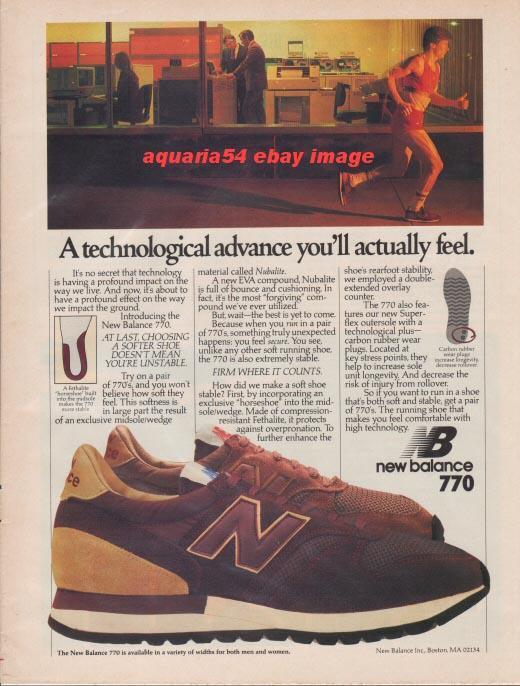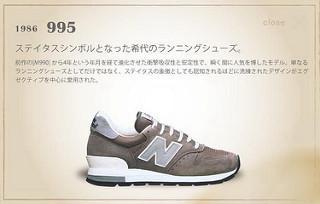The first image is the image on the left, the second image is the image on the right. For the images shown, is this caption "The shoes in each of the images are depicted in an advertisement." true? Answer yes or no. Yes. The first image is the image on the left, the second image is the image on the right. Assess this claim about the two images: "Left and right images contain the same number of sneakers displayed in the same position, and no human legs are depicted anywhere in either image.". Correct or not? Answer yes or no. No. 